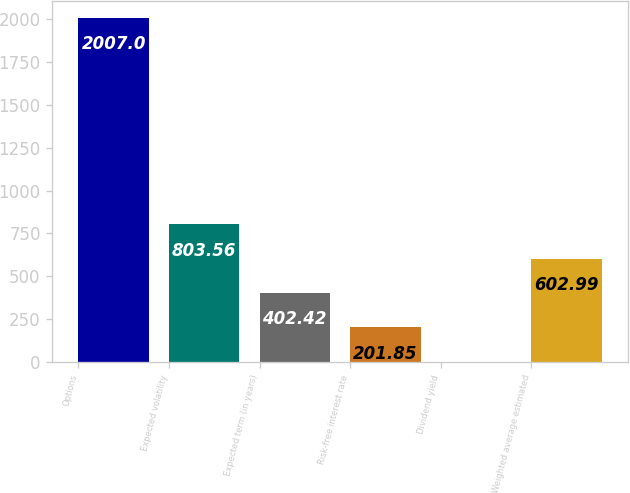Convert chart to OTSL. <chart><loc_0><loc_0><loc_500><loc_500><bar_chart><fcel>Options<fcel>Expected volatility<fcel>Expected term (in years)<fcel>Risk-free interest rate<fcel>Dividend yield<fcel>Weighted average estimated<nl><fcel>2007<fcel>803.56<fcel>402.42<fcel>201.85<fcel>1.28<fcel>602.99<nl></chart> 